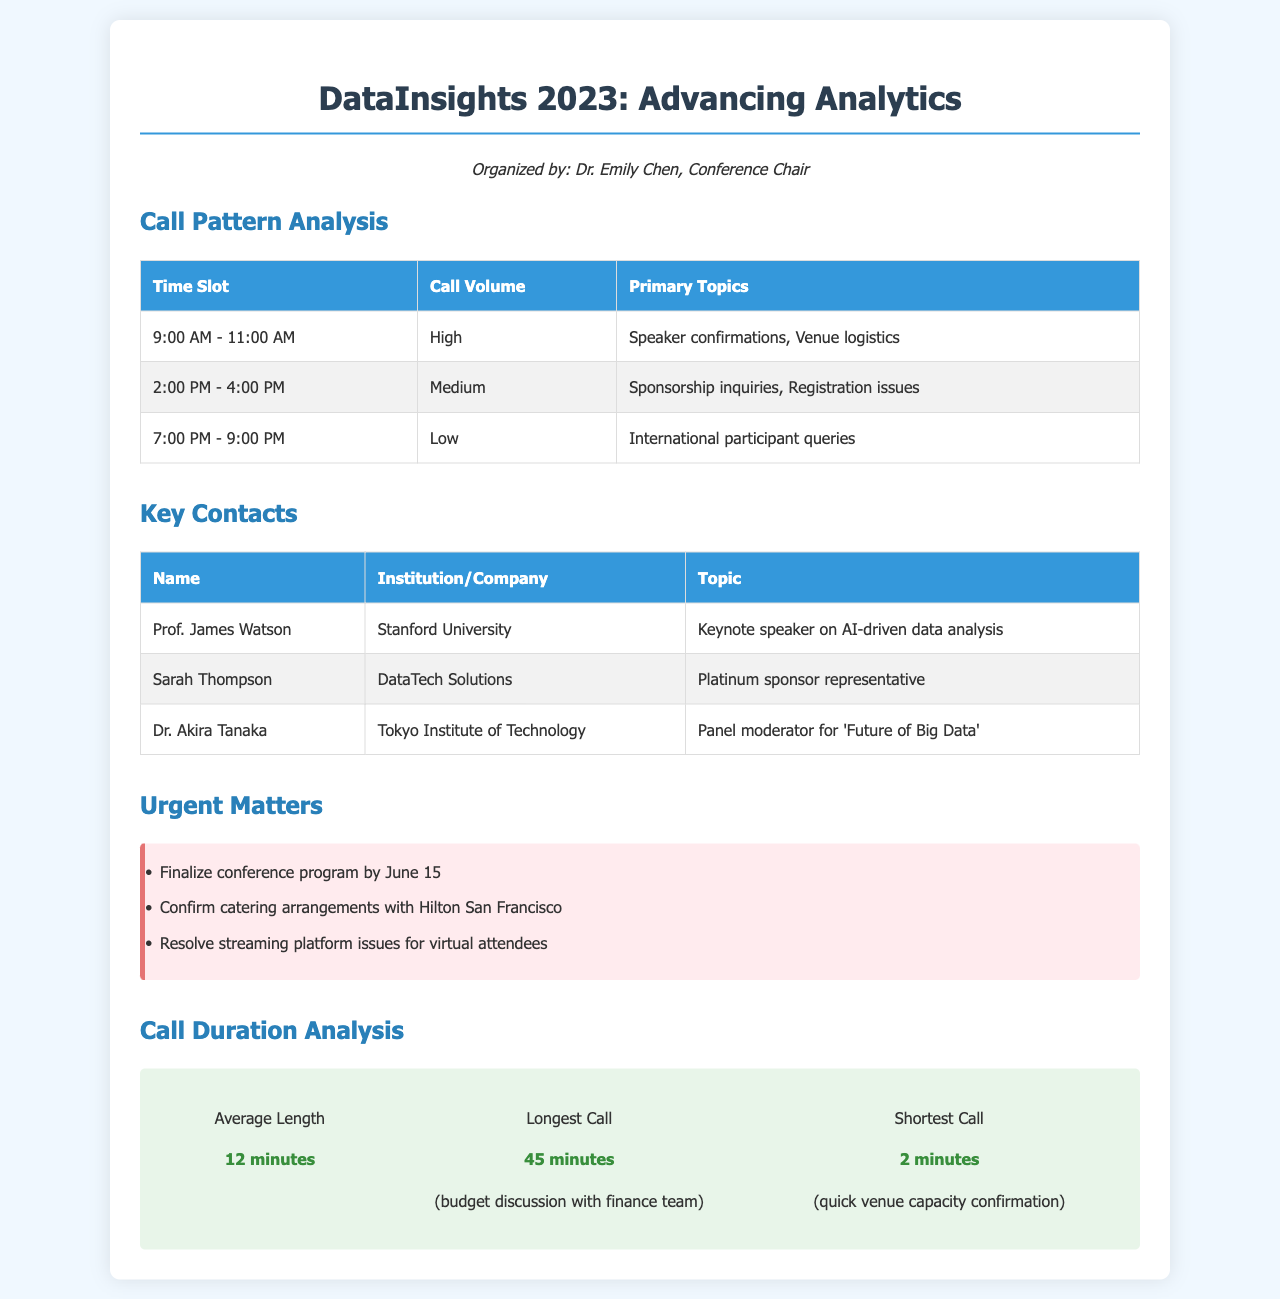What time slot has the highest call volume? The highest call volume is reported for the time slot of 9:00 AM to 11:00 AM.
Answer: 9:00 AM - 11:00 AM Who is the keynote speaker on AI-driven data analysis? The keynote speaker on AI-driven data analysis is Prof. James Watson.
Answer: Prof. James Watson What is the average call length? The average length of calls is provided as 12 minutes.
Answer: 12 minutes What urgent matter needs to be finalized by June 15? The document states that the conference program must be finalized by June 15.
Answer: Conference program Which time slot has low call volume? The time slot with low call volume is listed as 7:00 PM to 9:00 PM.
Answer: 7:00 PM - 9:00 PM What is the primary topic discussed in the 2:00 PM to 4:00 PM time slot? The primary topics during this time slot include sponsorship inquiries and registration issues.
Answer: Sponsorship inquiries, registration issues Who is representing the platinum sponsor? Sarah Thompson is identified as the platinum sponsor representative.
Answer: Sarah Thompson What is the longest call duration recorded? The longest call duration recorded in the analysis is 45 minutes.
Answer: 45 minutes What is the shortest call duration recorded? The shortest call duration recorded in the document is 2 minutes.
Answer: 2 minutes 